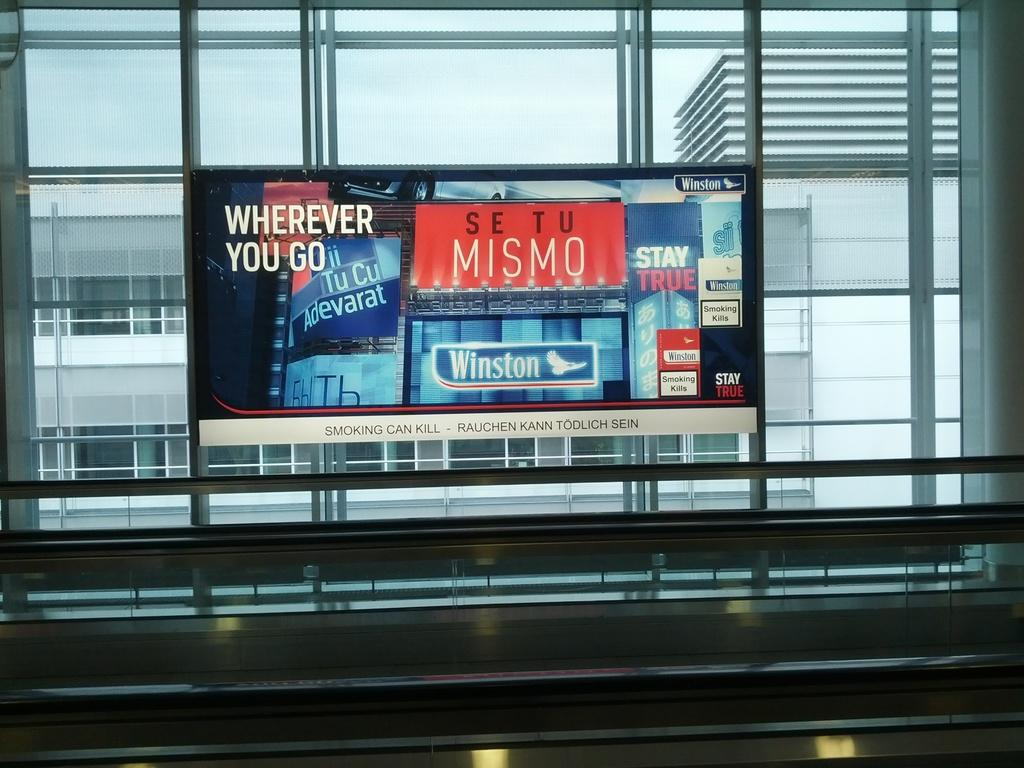<image>
Summarize the visual content of the image. A poster by a moving sidewalk is sponsored by Winston. 